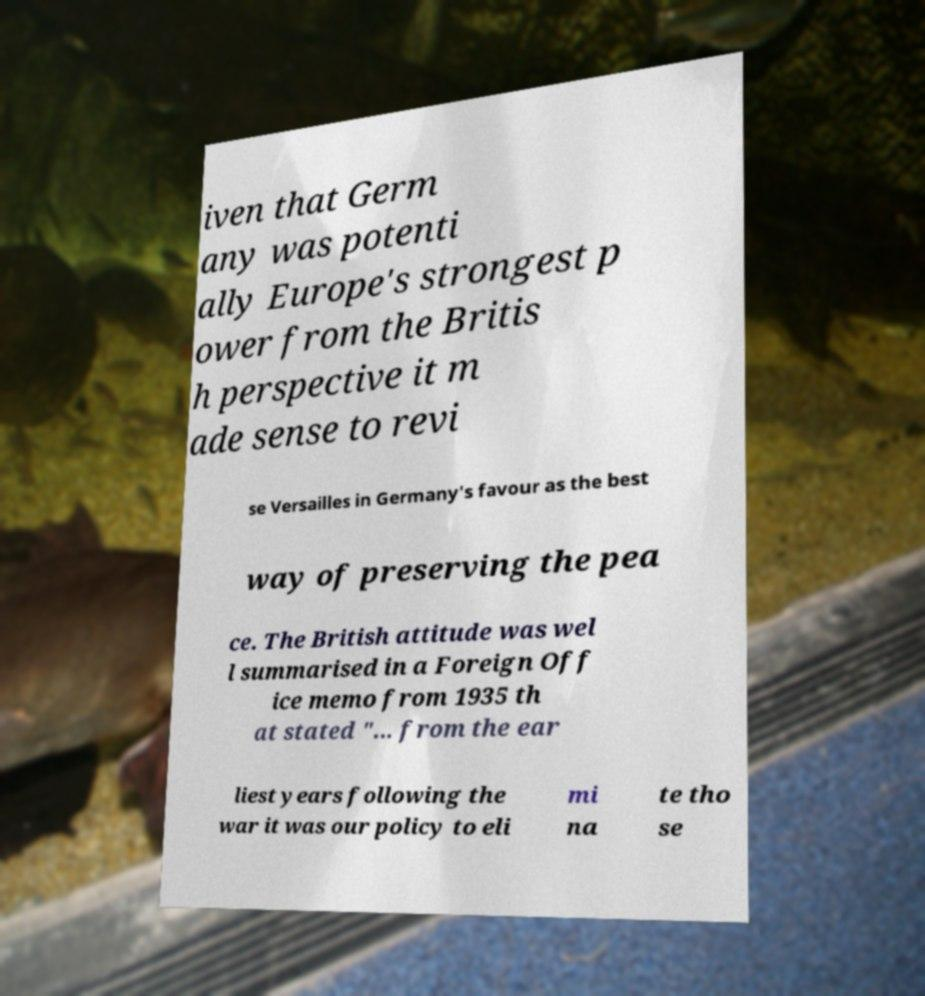Can you accurately transcribe the text from the provided image for me? iven that Germ any was potenti ally Europe's strongest p ower from the Britis h perspective it m ade sense to revi se Versailles in Germany's favour as the best way of preserving the pea ce. The British attitude was wel l summarised in a Foreign Off ice memo from 1935 th at stated "... from the ear liest years following the war it was our policy to eli mi na te tho se 